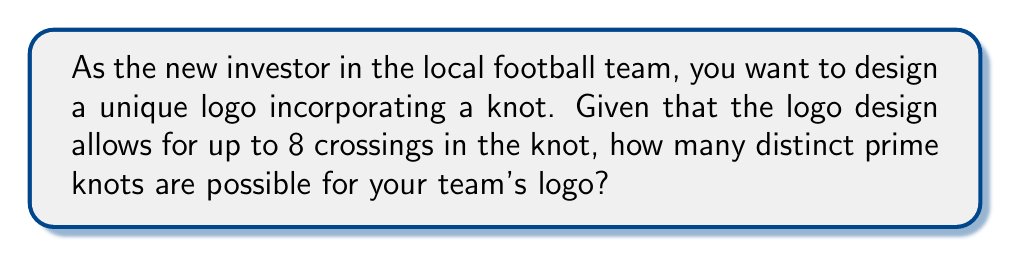Can you solve this math problem? To solve this problem, we need to understand the concept of prime knots in knot theory:

1. Prime knots are knots that cannot be decomposed into simpler knots.
2. The number of prime knots increases rapidly with the number of crossings.

Let's break down the number of prime knots for each crossing number up to 8:

1. 0 crossings: 1 prime knot (the unknot)
2. 3 crossings: 1 prime knot (trefoil knot)
3. 4 crossings: 1 prime knot (figure-eight knot)
4. 5 crossings: 2 prime knots
5. 6 crossings: 3 prime knots
6. 7 crossings: 7 prime knots
7. 8 crossings: 21 prime knots

To calculate the total number of distinct prime knots possible for the logo, we sum up all the prime knots from 0 to 8 crossings:

$$\text{Total prime knots} = 1 + 1 + 1 + 2 + 3 + 7 + 21 = 36$$

Therefore, there are 36 distinct prime knots possible for the team's logo design with up to 8 crossings.
Answer: 36 prime knots 